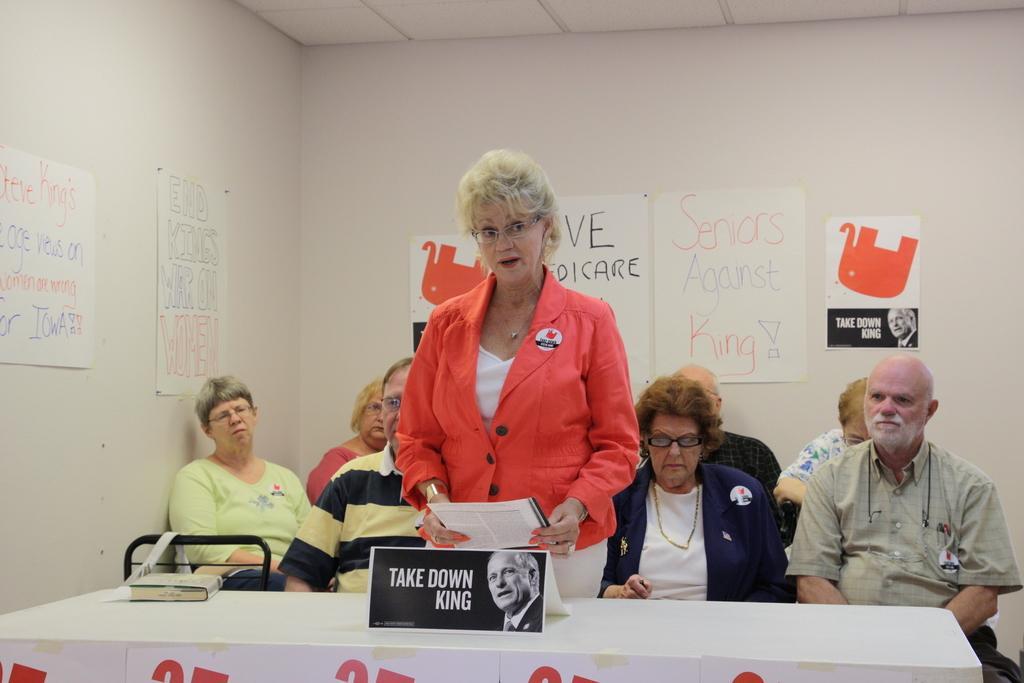How would you summarize this image in a sentence or two? In this image I can see few people where a woman is standing and rest all are sitting. here on this table I can see a board and a book. On these walls I can see few posts. 